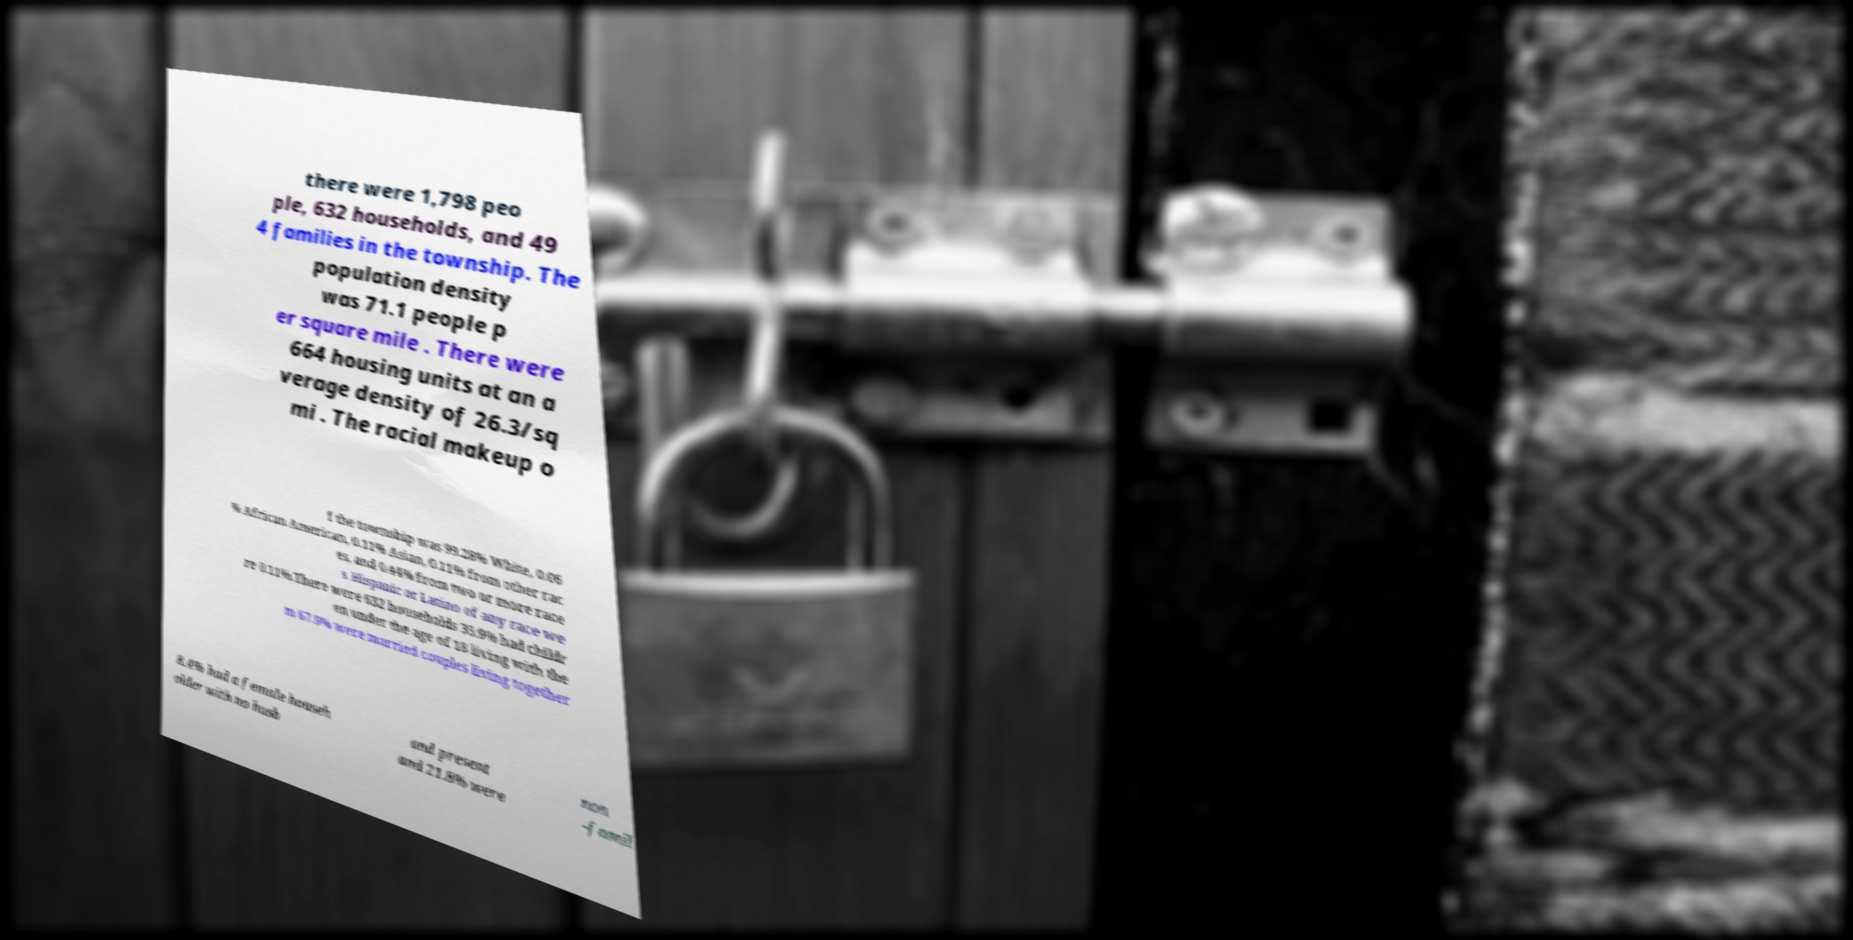Please read and relay the text visible in this image. What does it say? there were 1,798 peo ple, 632 households, and 49 4 families in the township. The population density was 71.1 people p er square mile . There were 664 housing units at an a verage density of 26.3/sq mi . The racial makeup o f the township was 99.28% White, 0.06 % African American, 0.11% Asian, 0.11% from other rac es, and 0.44% from two or more race s. Hispanic or Latino of any race we re 0.11%.There were 632 households 35.9% had childr en under the age of 18 living with the m 67.9% were married couples living together 8.4% had a female househ older with no husb and present and 21.8% were non -famil 